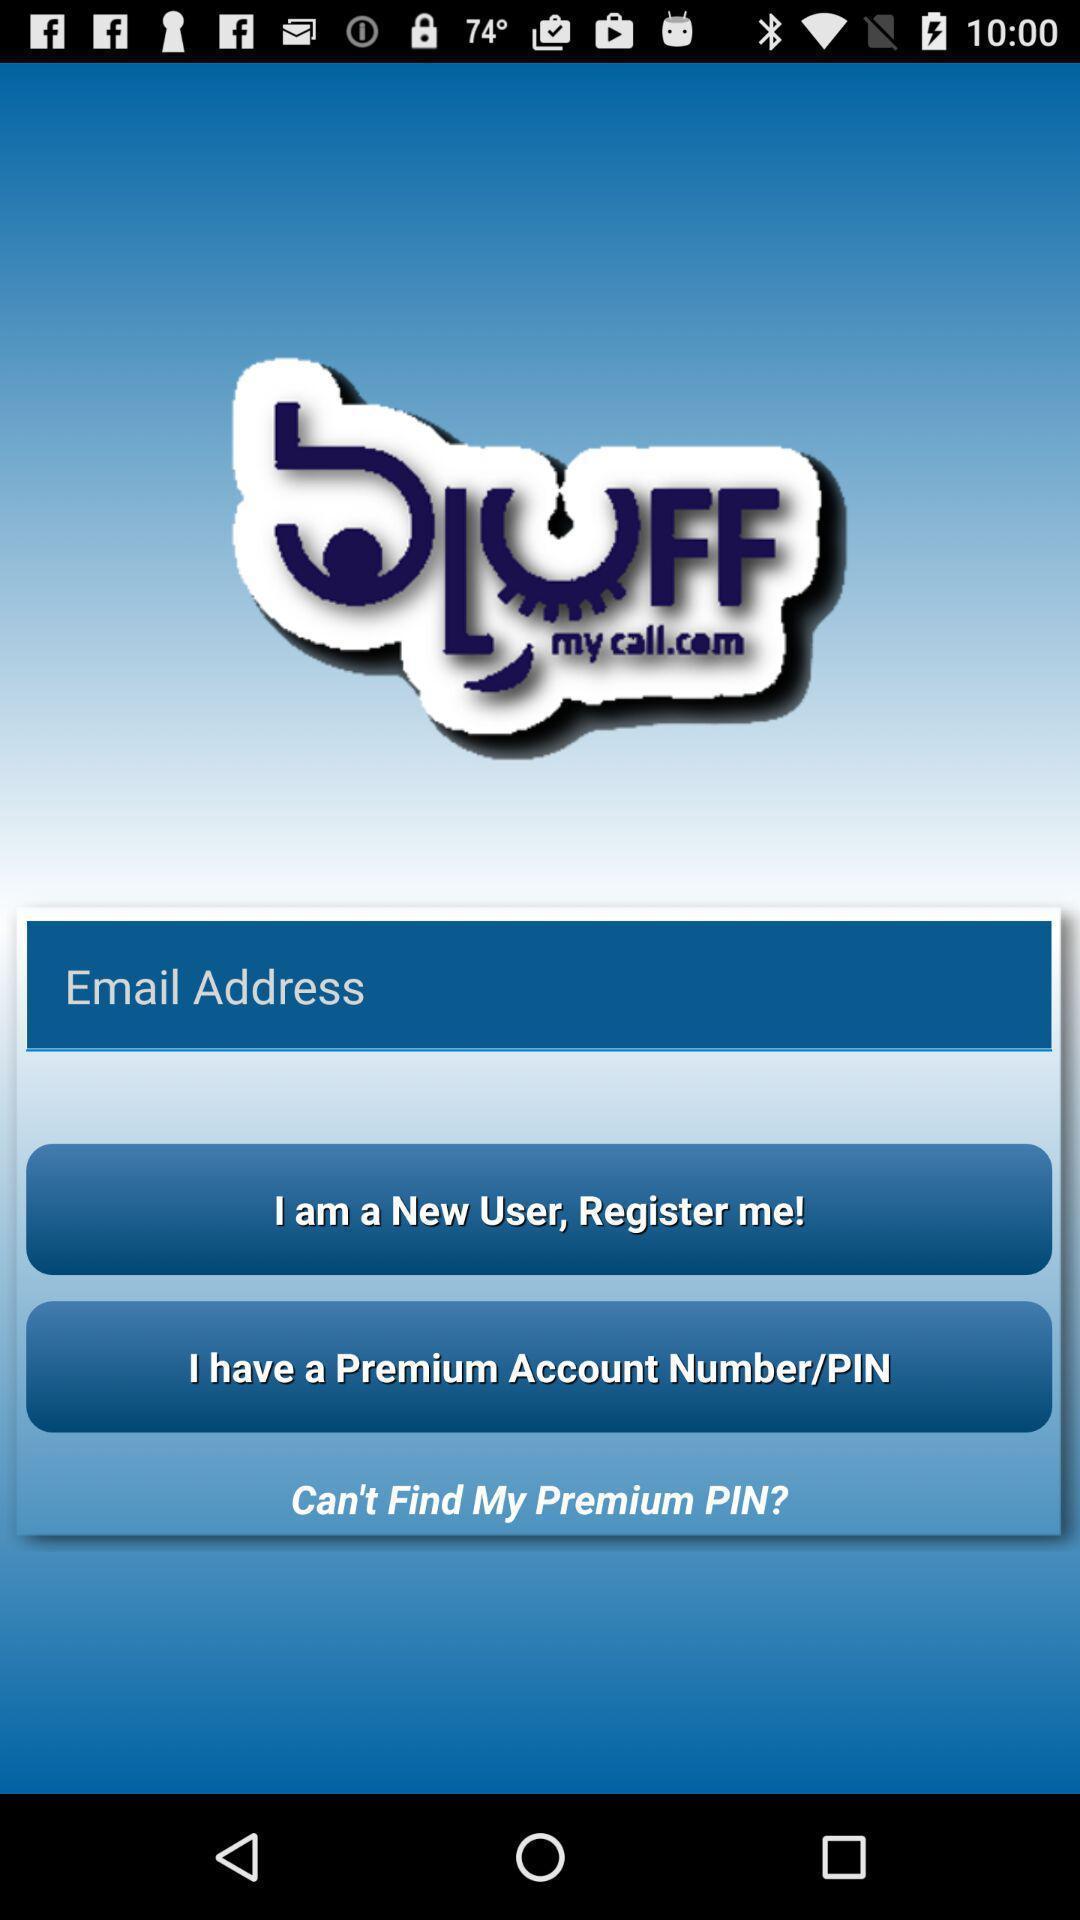Give me a narrative description of this picture. Page showing about login information. 